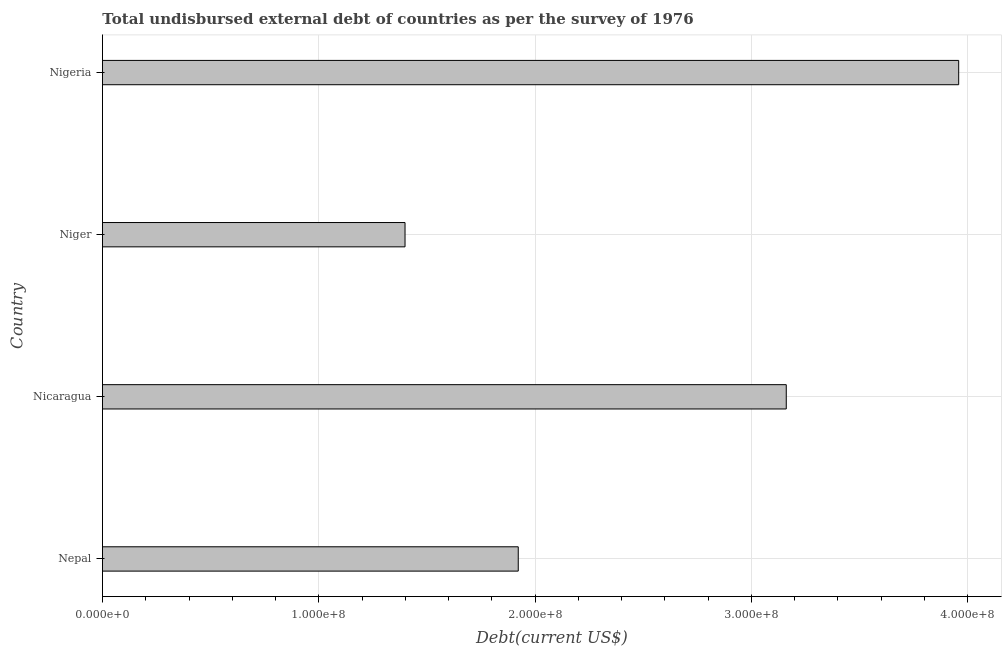What is the title of the graph?
Your answer should be very brief. Total undisbursed external debt of countries as per the survey of 1976. What is the label or title of the X-axis?
Ensure brevity in your answer.  Debt(current US$). What is the total debt in Nigeria?
Your response must be concise. 3.96e+08. Across all countries, what is the maximum total debt?
Offer a terse response. 3.96e+08. Across all countries, what is the minimum total debt?
Make the answer very short. 1.40e+08. In which country was the total debt maximum?
Provide a short and direct response. Nigeria. In which country was the total debt minimum?
Provide a short and direct response. Niger. What is the sum of the total debt?
Offer a very short reply. 1.04e+09. What is the difference between the total debt in Nicaragua and Niger?
Ensure brevity in your answer.  1.76e+08. What is the average total debt per country?
Provide a short and direct response. 2.61e+08. What is the median total debt?
Offer a terse response. 2.54e+08. In how many countries, is the total debt greater than 300000000 US$?
Offer a very short reply. 2. What is the ratio of the total debt in Nepal to that in Nicaragua?
Your answer should be compact. 0.61. Is the difference between the total debt in Nicaragua and Niger greater than the difference between any two countries?
Give a very brief answer. No. What is the difference between the highest and the second highest total debt?
Offer a very short reply. 7.97e+07. What is the difference between the highest and the lowest total debt?
Offer a very short reply. 2.56e+08. What is the Debt(current US$) in Nepal?
Keep it short and to the point. 1.92e+08. What is the Debt(current US$) in Nicaragua?
Keep it short and to the point. 3.16e+08. What is the Debt(current US$) of Niger?
Keep it short and to the point. 1.40e+08. What is the Debt(current US$) in Nigeria?
Provide a short and direct response. 3.96e+08. What is the difference between the Debt(current US$) in Nepal and Nicaragua?
Provide a short and direct response. -1.24e+08. What is the difference between the Debt(current US$) in Nepal and Niger?
Offer a terse response. 5.23e+07. What is the difference between the Debt(current US$) in Nepal and Nigeria?
Your answer should be very brief. -2.04e+08. What is the difference between the Debt(current US$) in Nicaragua and Niger?
Keep it short and to the point. 1.76e+08. What is the difference between the Debt(current US$) in Nicaragua and Nigeria?
Keep it short and to the point. -7.97e+07. What is the difference between the Debt(current US$) in Niger and Nigeria?
Provide a short and direct response. -2.56e+08. What is the ratio of the Debt(current US$) in Nepal to that in Nicaragua?
Give a very brief answer. 0.61. What is the ratio of the Debt(current US$) in Nepal to that in Niger?
Your response must be concise. 1.37. What is the ratio of the Debt(current US$) in Nepal to that in Nigeria?
Provide a short and direct response. 0.49. What is the ratio of the Debt(current US$) in Nicaragua to that in Niger?
Make the answer very short. 2.26. What is the ratio of the Debt(current US$) in Nicaragua to that in Nigeria?
Make the answer very short. 0.8. What is the ratio of the Debt(current US$) in Niger to that in Nigeria?
Provide a succinct answer. 0.35. 